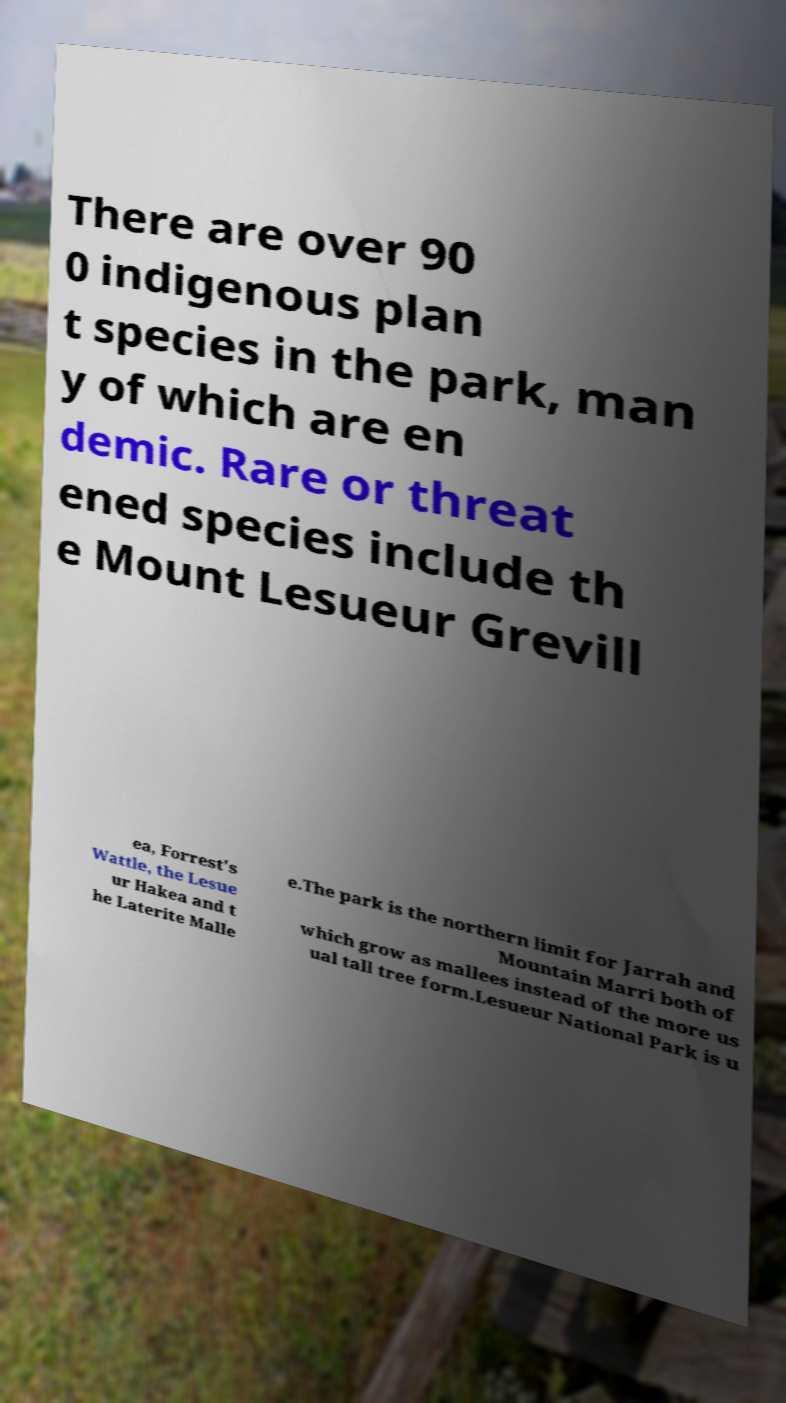I need the written content from this picture converted into text. Can you do that? There are over 90 0 indigenous plan t species in the park, man y of which are en demic. Rare or threat ened species include th e Mount Lesueur Grevill ea, Forrest's Wattle, the Lesue ur Hakea and t he Laterite Malle e.The park is the northern limit for Jarrah and Mountain Marri both of which grow as mallees instead of the more us ual tall tree form.Lesueur National Park is u 